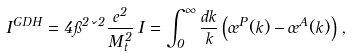<formula> <loc_0><loc_0><loc_500><loc_500>I ^ { G D H } = 4 \pi ^ { 2 } \kappa ^ { 2 } \frac { e ^ { 2 } } { M _ { t } ^ { 2 } } \, I = \int _ { 0 } ^ { \infty } \frac { d k } { k } \left ( \sigma ^ { P } ( k ) - \sigma ^ { A } ( k ) \right ) \, ,</formula> 